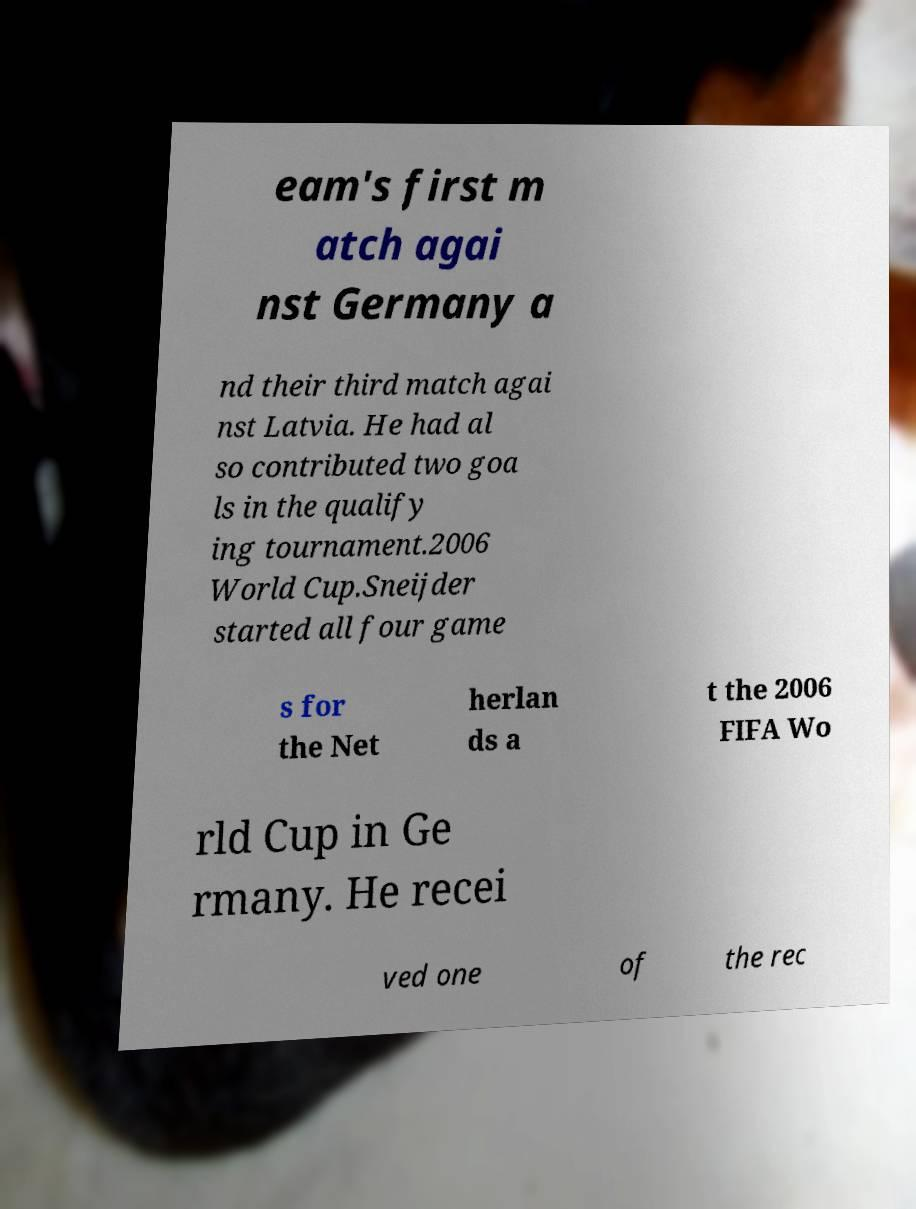There's text embedded in this image that I need extracted. Can you transcribe it verbatim? eam's first m atch agai nst Germany a nd their third match agai nst Latvia. He had al so contributed two goa ls in the qualify ing tournament.2006 World Cup.Sneijder started all four game s for the Net herlan ds a t the 2006 FIFA Wo rld Cup in Ge rmany. He recei ved one of the rec 